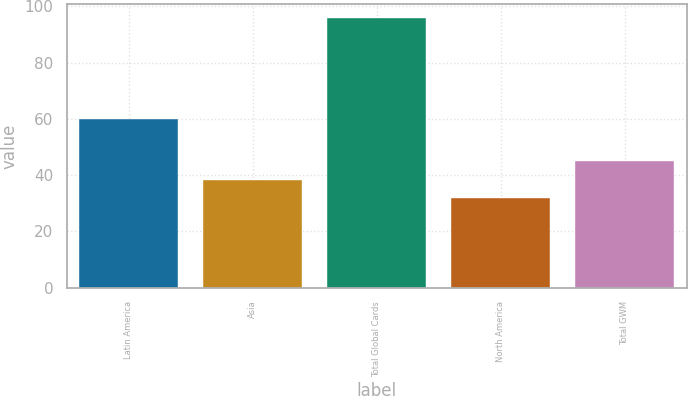Convert chart to OTSL. <chart><loc_0><loc_0><loc_500><loc_500><bar_chart><fcel>Latin America<fcel>Asia<fcel>Total Global Cards<fcel>North America<fcel>Total GWM<nl><fcel>60<fcel>38.4<fcel>96<fcel>32<fcel>45<nl></chart> 